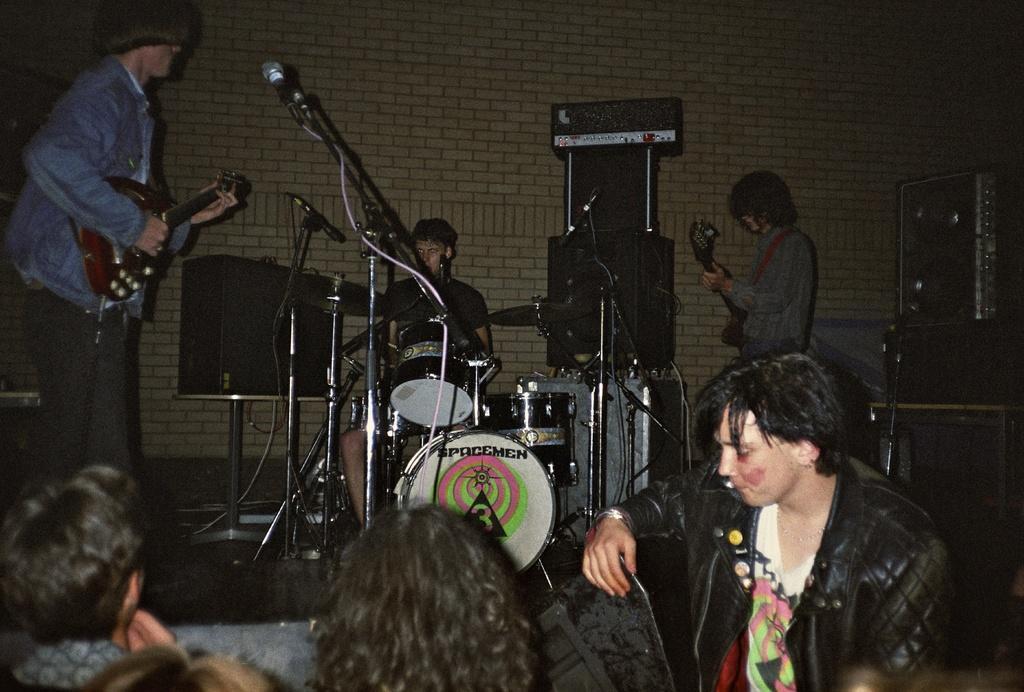Could you give a brief overview of what you see in this image? In this picture, there are three people playing musical instruments. Among them, two are playing guitars. In the middle, there is a man playing drums. Before him, there are mike's. At the bottom, there are people. At the bottom right, there is a person in black jacket. In the background there is a brick wall. Towards the right, there are sound speakers. 